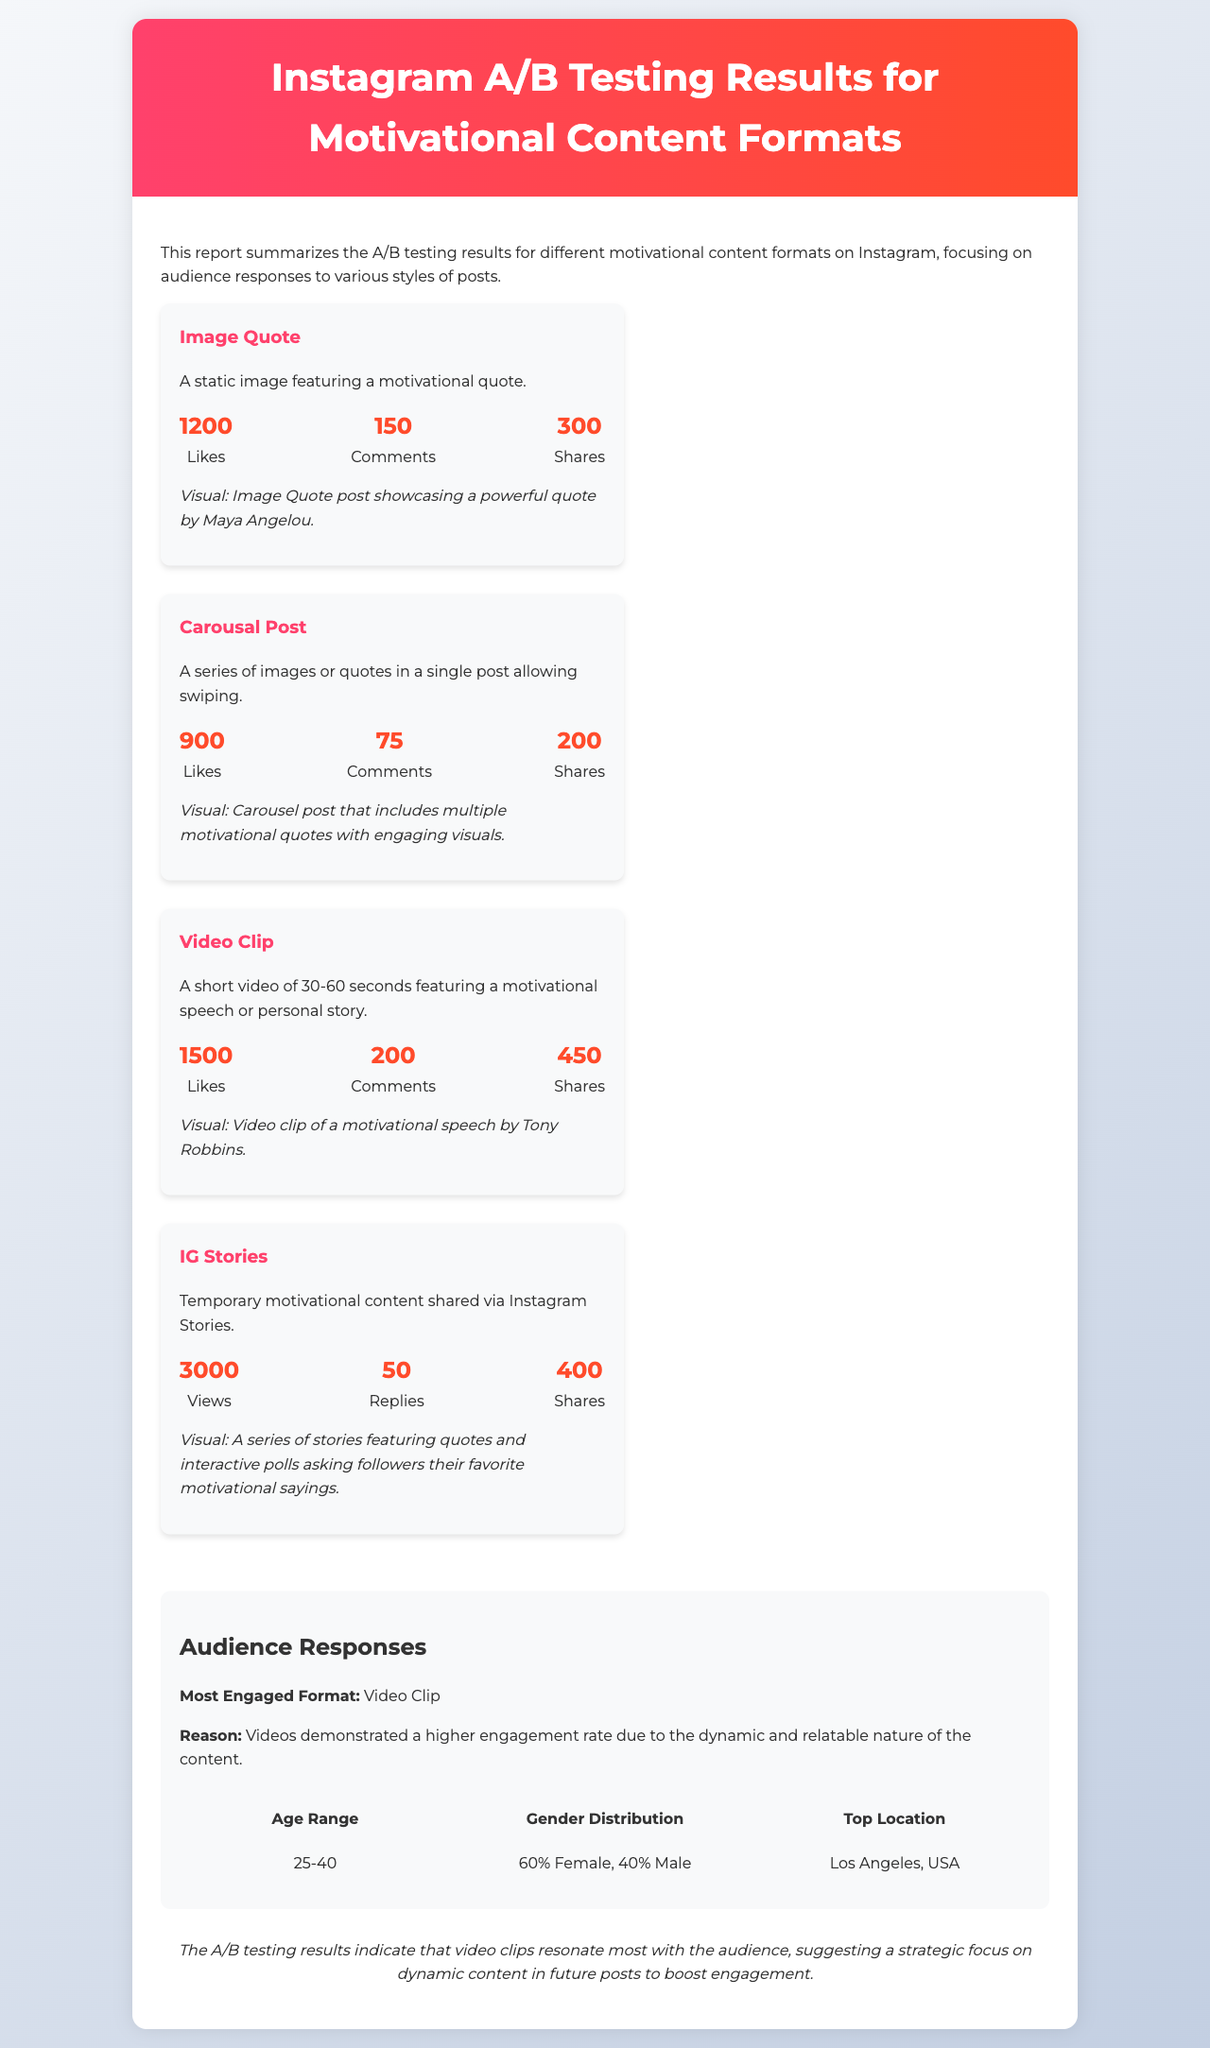What is the most engaged format? The most engaged format is determined by analyzing audience responses, and it is stated as video clip in the document.
Answer: Video Clip How many likes did the Image Quote receive? The document specifies the number of likes for the Image Quote, which is given directly.
Answer: 1200 What percentage of the audience is female? The document provides demographic information, specifically noting the gender distribution among the audience.
Answer: 60% Which motivational content format received the most shares? This question examines the metrics for content formats to find which one performed best in terms of shares.
Answer: IG Stories What is the top location of the audience? The document mentions the geographical location of the audience, specifying where the majority are based.
Answer: Los Angeles, USA What was the main reason for the video clip being the most engaged format? The document offers insight into why the video format resonated more with the audience, requiring interpretation of content analysis.
Answer: Dynamic and relatable nature How many comments did the Carousal Post get? The number of comments for the Carousal Post is clearly stated in the metrics presented in the document.
Answer: 75 What type of post includes a motivational speech? This question focuses on identifying the content type that features a speech within its description.
Answer: Video Clip What are the views for IG Stories? The document includes concrete metrics for IG Stories, directly answering this question.
Answer: 3000 